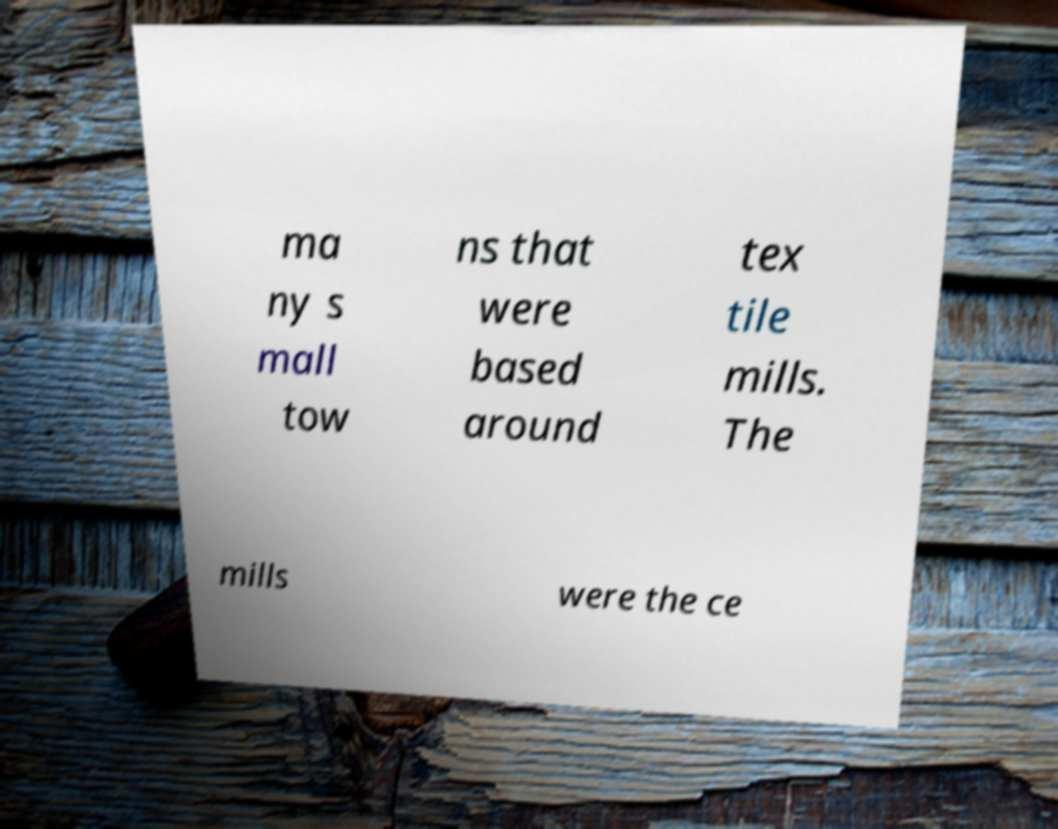I need the written content from this picture converted into text. Can you do that? ma ny s mall tow ns that were based around tex tile mills. The mills were the ce 